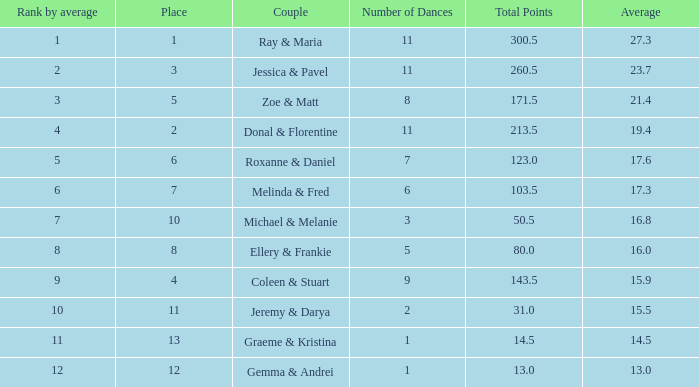Who are the couple with a rank of 9 based on their average score? Coleen & Stuart. 